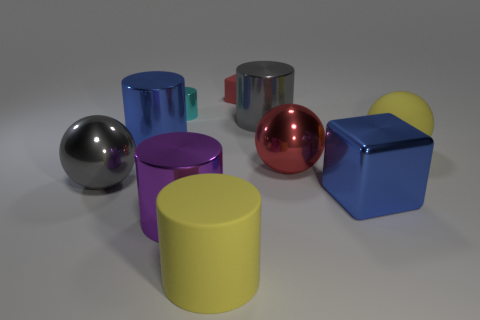What number of large rubber balls are right of the yellow matte object on the right side of the big gray shiny cylinder?
Offer a terse response. 0. There is a matte object that is in front of the small cylinder and on the left side of the big blue metal block; what is its shape?
Your answer should be compact. Cylinder. What is the gray object to the right of the gray metal thing left of the large metal cylinder left of the purple cylinder made of?
Your response must be concise. Metal. What size is the metal object that is the same color as the small rubber cube?
Give a very brief answer. Large. What material is the gray cylinder?
Give a very brief answer. Metal. Does the big blue cylinder have the same material as the yellow thing that is behind the blue cube?
Your answer should be compact. No. What color is the rubber thing that is behind the gray metal object that is to the right of the small red matte block?
Give a very brief answer. Red. There is a ball that is both left of the large block and right of the small red matte block; what size is it?
Provide a succinct answer. Large. What number of other objects are the same shape as the red matte object?
Offer a very short reply. 1. Do the large red shiny thing and the rubber object that is on the right side of the large metal cube have the same shape?
Provide a short and direct response. Yes. 